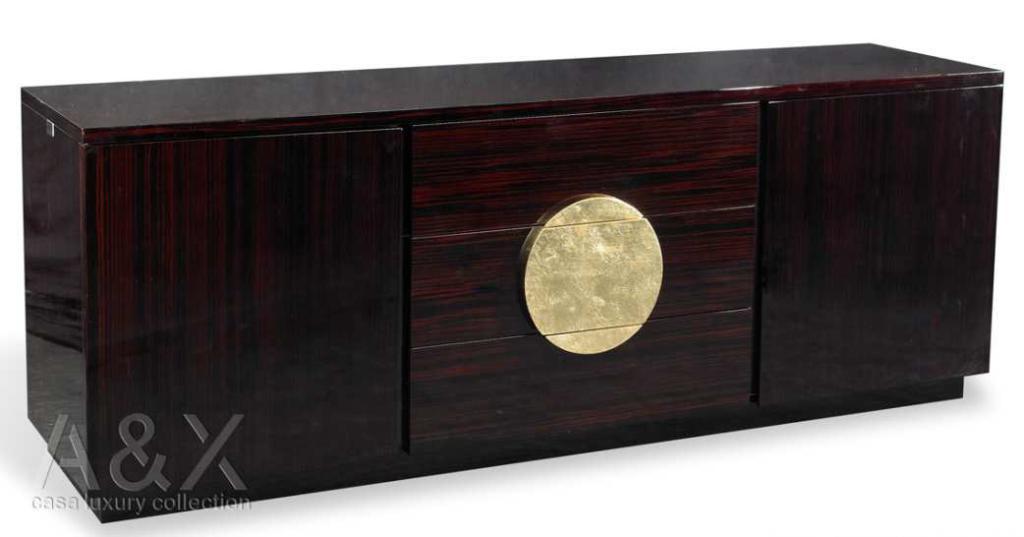What type of object is in the image? There is a wooden box in the image. How many shelves does the wooden box have? The wooden box has three shelves. What is the name of the vegetable that is operating the machine in the image? There is no machine or vegetable present in the image; it only features a wooden box with three shelves. 